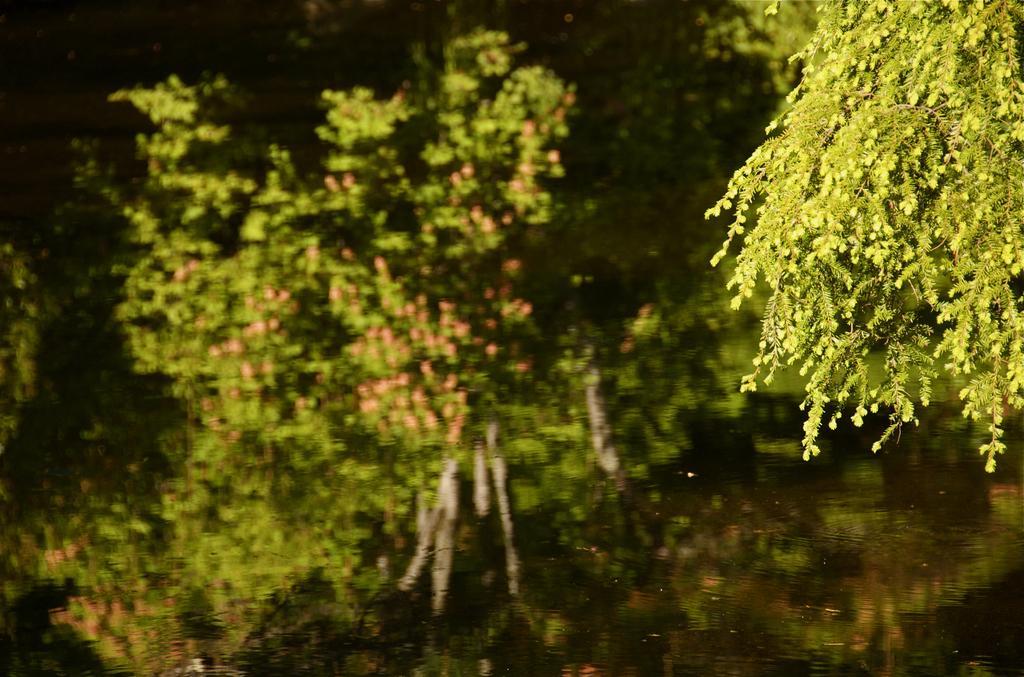How would you summarize this image in a sentence or two? In this image at the bottom there is one pond, in the foreground and background there are some plants. 